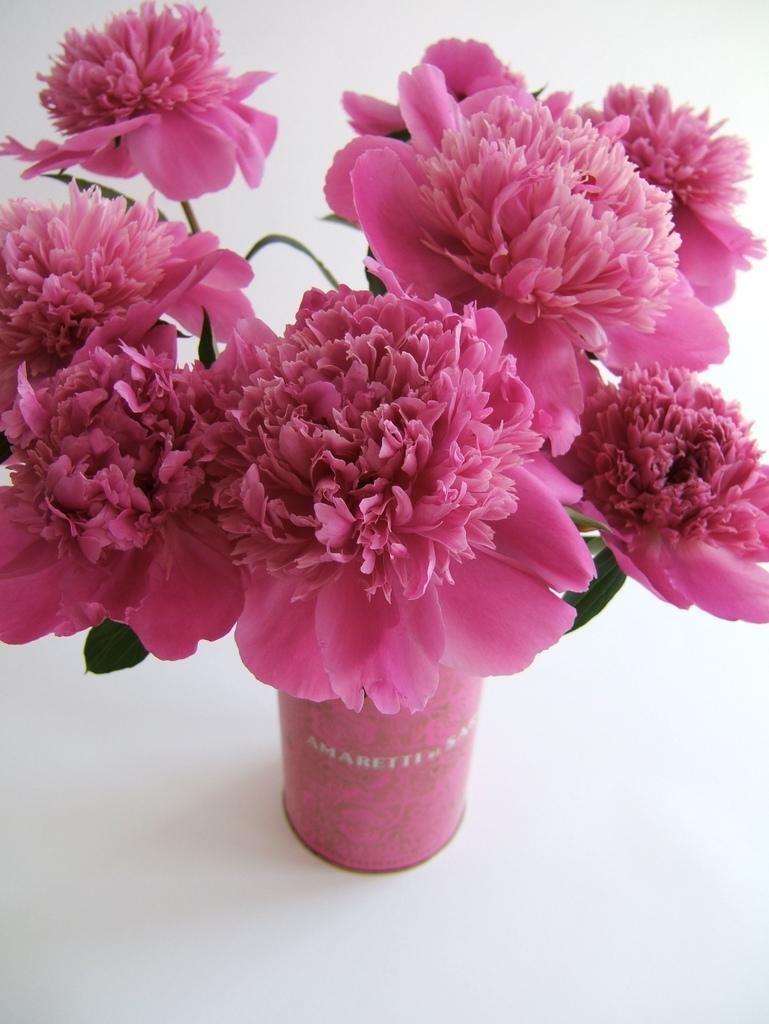How would you summarize this image in a sentence or two? This image consists of a plant. There are flowers in pink color is kept on the floor. 